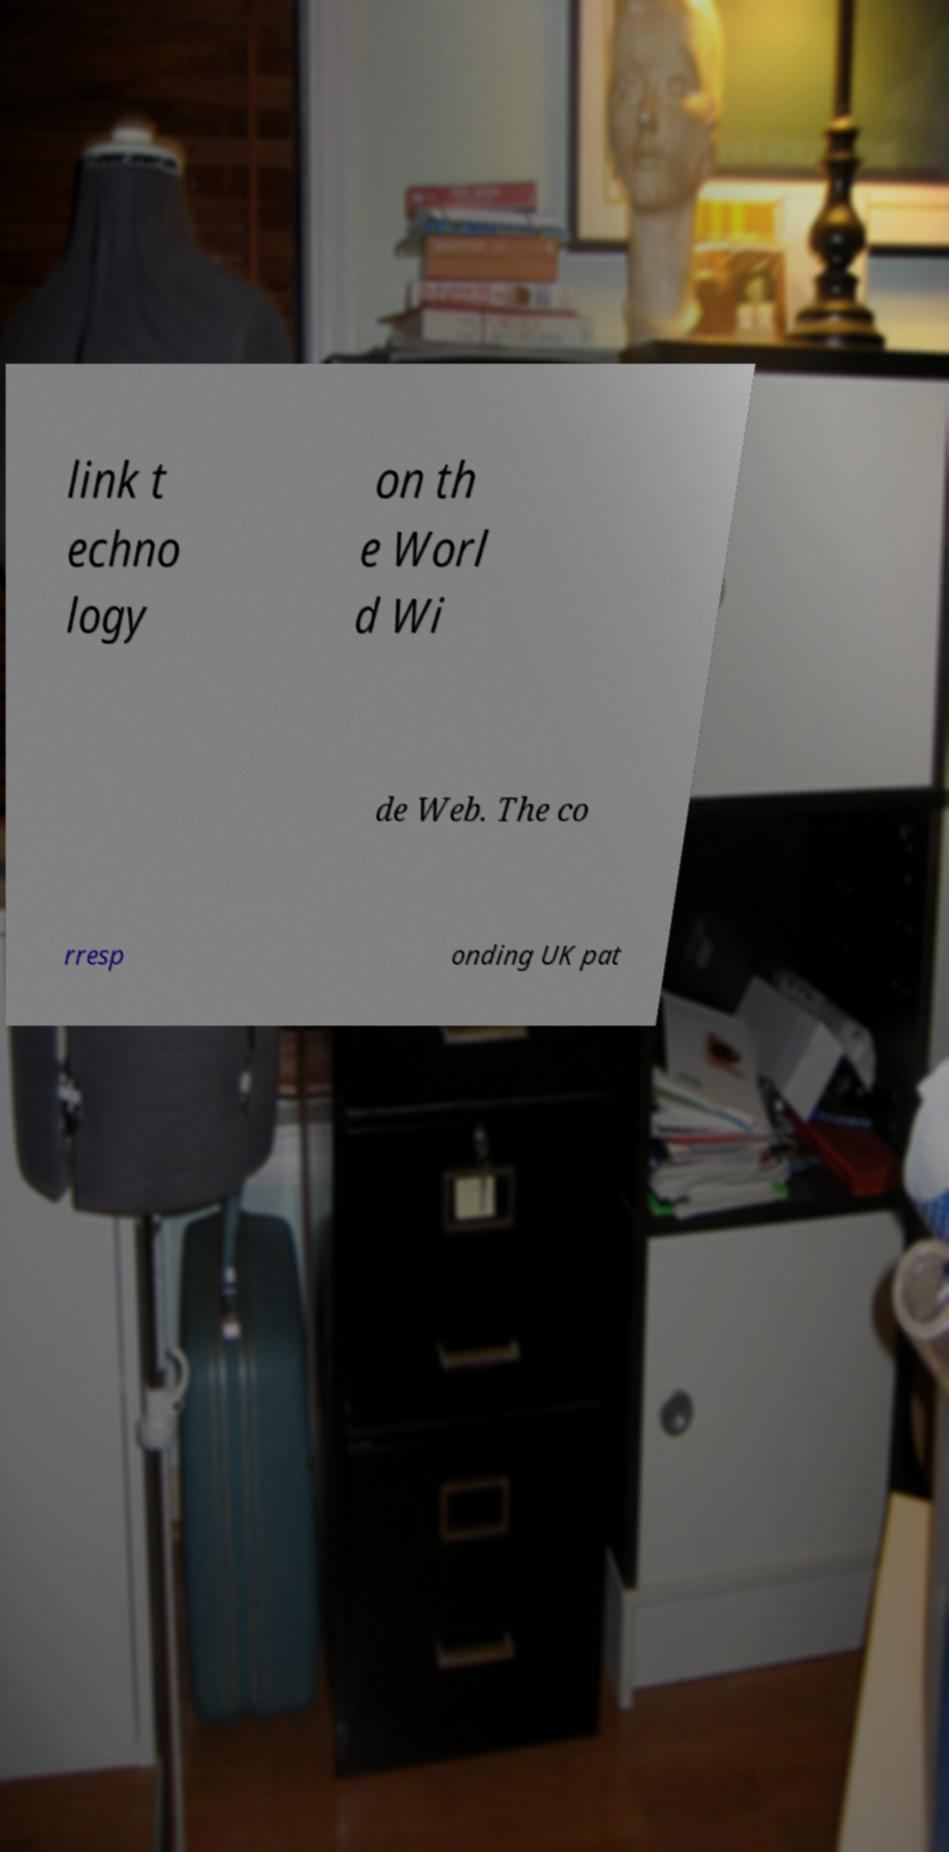Please read and relay the text visible in this image. What does it say? link t echno logy on th e Worl d Wi de Web. The co rresp onding UK pat 